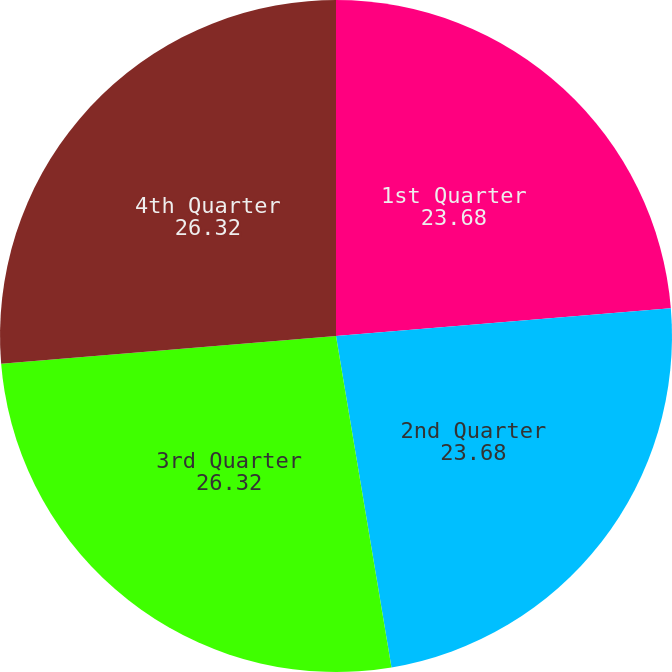Convert chart to OTSL. <chart><loc_0><loc_0><loc_500><loc_500><pie_chart><fcel>1st Quarter<fcel>2nd Quarter<fcel>3rd Quarter<fcel>4th Quarter<nl><fcel>23.68%<fcel>23.68%<fcel>26.32%<fcel>26.32%<nl></chart> 